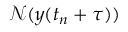Convert formula to latex. <formula><loc_0><loc_0><loc_500><loc_500>{ \mathcal { N } } ( y ( t _ { n } + \tau ) )</formula> 